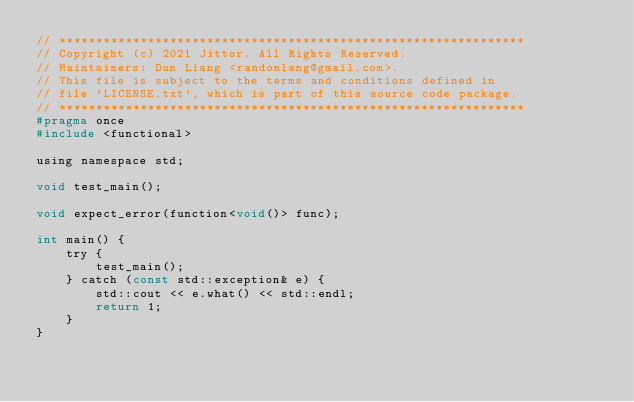Convert code to text. <code><loc_0><loc_0><loc_500><loc_500><_C_>// ***************************************************************
// Copyright (c) 2021 Jittor. All Rights Reserved. 
// Maintainers: Dun Liang <randonlang@gmail.com>. 
// This file is subject to the terms and conditions defined in
// file 'LICENSE.txt', which is part of this source code package.
// ***************************************************************
#pragma once
#include <functional>

using namespace std;

void test_main();

void expect_error(function<void()> func);

int main() {
    try {
        test_main();
    } catch (const std::exception& e) {
        std::cout << e.what() << std::endl;
        return 1;
    }
}</code> 